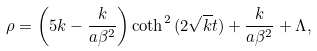<formula> <loc_0><loc_0><loc_500><loc_500>\rho = \left ( 5 k - \frac { k } { a \beta ^ { 2 } } \right ) \coth ^ { 2 } { ( 2 \sqrt { k } t ) } + \frac { k } { a \beta ^ { 2 } } + \Lambda ,</formula> 